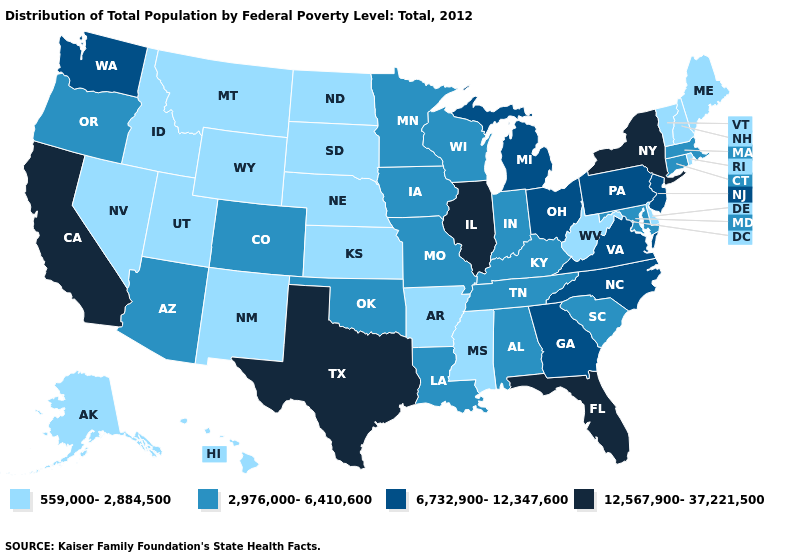Among the states that border North Carolina , which have the highest value?
Short answer required. Georgia, Virginia. Name the states that have a value in the range 559,000-2,884,500?
Answer briefly. Alaska, Arkansas, Delaware, Hawaii, Idaho, Kansas, Maine, Mississippi, Montana, Nebraska, Nevada, New Hampshire, New Mexico, North Dakota, Rhode Island, South Dakota, Utah, Vermont, West Virginia, Wyoming. Does Colorado have the highest value in the West?
Give a very brief answer. No. Does Oregon have a lower value than Texas?
Write a very short answer. Yes. Name the states that have a value in the range 2,976,000-6,410,600?
Short answer required. Alabama, Arizona, Colorado, Connecticut, Indiana, Iowa, Kentucky, Louisiana, Maryland, Massachusetts, Minnesota, Missouri, Oklahoma, Oregon, South Carolina, Tennessee, Wisconsin. Name the states that have a value in the range 6,732,900-12,347,600?
Short answer required. Georgia, Michigan, New Jersey, North Carolina, Ohio, Pennsylvania, Virginia, Washington. Name the states that have a value in the range 12,567,900-37,221,500?
Concise answer only. California, Florida, Illinois, New York, Texas. What is the highest value in the USA?
Answer briefly. 12,567,900-37,221,500. What is the highest value in the Northeast ?
Give a very brief answer. 12,567,900-37,221,500. Which states hav the highest value in the South?
Give a very brief answer. Florida, Texas. Name the states that have a value in the range 2,976,000-6,410,600?
Keep it brief. Alabama, Arizona, Colorado, Connecticut, Indiana, Iowa, Kentucky, Louisiana, Maryland, Massachusetts, Minnesota, Missouri, Oklahoma, Oregon, South Carolina, Tennessee, Wisconsin. What is the value of Georgia?
Answer briefly. 6,732,900-12,347,600. What is the value of Oregon?
Be succinct. 2,976,000-6,410,600. Which states have the lowest value in the USA?
Give a very brief answer. Alaska, Arkansas, Delaware, Hawaii, Idaho, Kansas, Maine, Mississippi, Montana, Nebraska, Nevada, New Hampshire, New Mexico, North Dakota, Rhode Island, South Dakota, Utah, Vermont, West Virginia, Wyoming. 